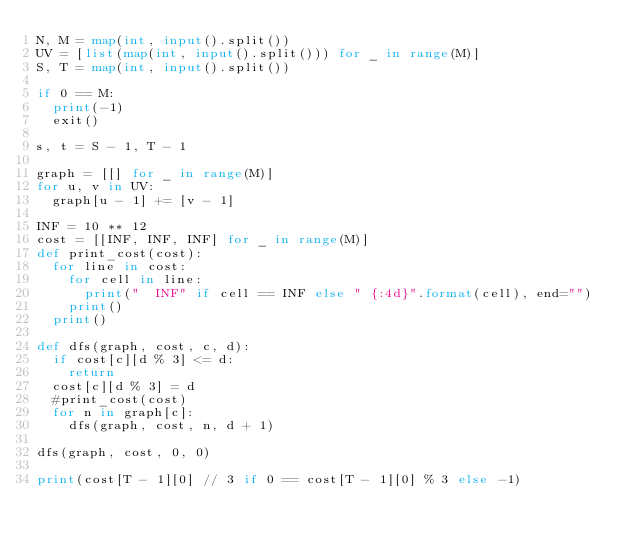Convert code to text. <code><loc_0><loc_0><loc_500><loc_500><_Python_>N, M = map(int, input().split())
UV = [list(map(int, input().split())) for _ in range(M)]
S, T = map(int, input().split())

if 0 == M:
	print(-1)
	exit()

s, t = S - 1, T - 1

graph = [[] for _ in range(M)]
for u, v in UV:
	graph[u - 1] += [v - 1]

INF = 10 ** 12
cost = [[INF, INF, INF] for _ in range(M)]
def print_cost(cost):
	for line in cost:
		for cell in line:
			print("  INF" if cell == INF else " {:4d}".format(cell), end="")
		print()
	print()

def dfs(graph, cost, c, d):
	if cost[c][d % 3] <= d:
		return
	cost[c][d % 3] = d
	#print_cost(cost)
	for n in graph[c]:
		dfs(graph, cost, n, d + 1)

dfs(graph, cost, 0, 0)

print(cost[T - 1][0] // 3 if 0 == cost[T - 1][0] % 3 else -1)
</code> 